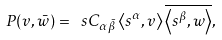Convert formula to latex. <formula><loc_0><loc_0><loc_500><loc_500>P ( v , \bar { w } ) = \ s C _ { \alpha \bar { \beta } } \left < s ^ { \alpha } , v \right > \overline { \left < s ^ { \beta } , w \right > } ,</formula> 